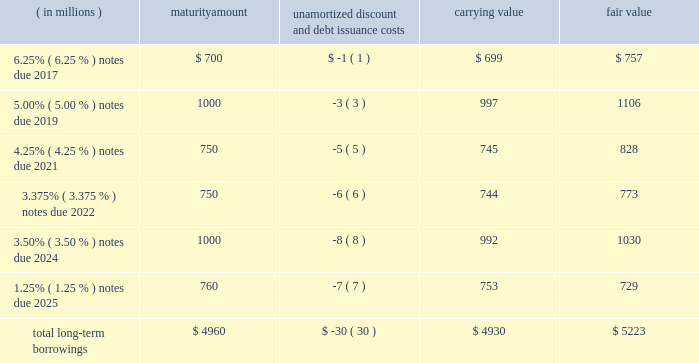12 .
Borrowings short-term borrowings 2015 revolving credit facility .
In march 2011 , the company entered into a five-year $ 3.5 billion unsecured revolving credit facility , which was amended in 2014 , 2013 and 2012 .
In april 2015 , the company 2019s credit facility was further amended to extend the maturity date to march 2020 and to increase the amount of the aggregate commitment to $ 4.0 billion ( the 201c2015 credit facility 201d ) .
The 2015 credit facility permits the company to request up to an additional $ 1.0 billion of borrowing capacity , subject to lender credit approval , increasing the overall size of the 2015 credit facility to an aggregate principal amount not to exceed $ 5.0 billion .
Interest on borrowings outstanding accrues at a rate based on the applicable london interbank offered rate plus a spread .
The 2015 credit facility requires the company not to exceed a maximum leverage ratio ( ratio of net debt to earnings before interest , taxes , depreciation and amortization , where net debt equals total debt less unrestricted cash ) of 3 to 1 , which was satisfied with a ratio of less than 1 to 1 at december 31 , 2015 .
The 2015 credit facility provides back-up liquidity to fund ongoing working capital for general corporate purposes and various investment opportunities .
At december 31 , 2015 , the company had no amount outstanding under the 2015 credit facility .
Commercial paper program .
On october 14 , 2009 , blackrock established a commercial paper program ( the 201ccp program 201d ) under which the company could issue unsecured commercial paper notes ( the 201ccp notes 201d ) on a private placement basis up to a maximum aggregate amount outstanding at any time of $ 4.0 billion as amended in april 2015 .
The cp program is currently supported by the 2015 credit facility .
At december 31 , 2015 , blackrock had no cp notes outstanding .
Long-term borrowings the carrying value and fair value of long-term borrowings estimated using market prices and foreign exchange rates at december 31 , 2015 included the following : ( in millions ) maturity amount unamortized discount and debt issuance costs carrying value fair value .
Long-term borrowings at december 31 , 2014 had a carrying value of $ 4.922 billion and a fair value of $ 5.309 billion determined using market prices at the end of december 2025 notes .
In may 2015 , the company issued 20ac700 million of 1.25% ( 1.25 % ) senior unsecured notes maturing on may 6 , 2025 ( the 201c2025 notes 201d ) .
The notes are listed on the new york stock exchange .
The net proceeds of the 2025 notes were used for general corporate purposes , including refinancing of outstanding indebtedness .
Interest of approximately $ 10 million per year based on current exchange rates is payable annually on may 6 of each year .
The 2025 notes may be redeemed in whole or in part prior to maturity at any time at the option of the company at a 201cmake-whole 201d redemption price .
The unamortized discount and debt issuance costs are being amortized over the remaining term of the 2025 notes .
Upon conversion to u.s .
Dollars the company designated the 20ac700 million debt offering as a net investment hedge to offset its currency exposure relating to its net investment in certain euro functional currency operations .
A gain of $ 19 million , net of tax , was recognized in other comprehensive income for 2015 .
No hedge ineffectiveness was recognized during 2015 .
2024 notes .
In march 2014 , the company issued $ 1.0 billion in aggregate principal amount of 3.50% ( 3.50 % ) senior unsecured and unsubordinated notes maturing on march 18 , 2024 ( the 201c2024 notes 201d ) .
The net proceeds of the 2024 notes were used to refinance certain indebtedness which matured in the fourth quarter of 2014 .
Interest is payable semi-annually in arrears on march 18 and september 18 of each year , or approximately $ 35 million per year .
The 2024 notes may be redeemed prior to maturity at any time in whole or in part at the option of the company at a 201cmake-whole 201d redemption price .
The unamortized discount and debt issuance costs are being amortized over the remaining term of the 2024 notes .
2022 notes .
In may 2012 , the company issued $ 1.5 billion in aggregate principal amount of unsecured unsubordinated obligations .
These notes were issued as two separate series of senior debt securities , including $ 750 million of 1.375% ( 1.375 % ) notes , which were repaid in june 2015 at maturity , and $ 750 million of 3.375% ( 3.375 % ) notes maturing in june 2022 ( the 201c2022 notes 201d ) .
Net proceeds were used to fund the repurchase of blackrock 2019s common stock and series b preferred from barclays and affiliates and for general corporate purposes .
Interest on the 2022 notes of approximately $ 25 million per year , respectively , is payable semi-annually on june 1 and december 1 of each year , which commenced december 1 , 2012 .
The 2022 notes may be redeemed prior to maturity at any time in whole or in part at the option of the company at a 201cmake-whole 201d redemption price .
The 201cmake-whole 201d redemption price represents a price , subject to the specific terms of the 2022 notes and related indenture , that is the greater of ( a ) par value and ( b ) the present value of future payments that will not be paid because of an early redemption , which is discounted at a fixed spread over a .
How much will the company pay in interest on the 2022 notes between 2012 and 2022 ? in millions $ .? 
Rationale: between 2013 and 2022 , 10 years of payments . payments done bianually ( so 20 half payments ) and 1 payment made in 2012
Computations: ((25 / 2) * ((10 * 2) + 1))
Answer: 262.5. 